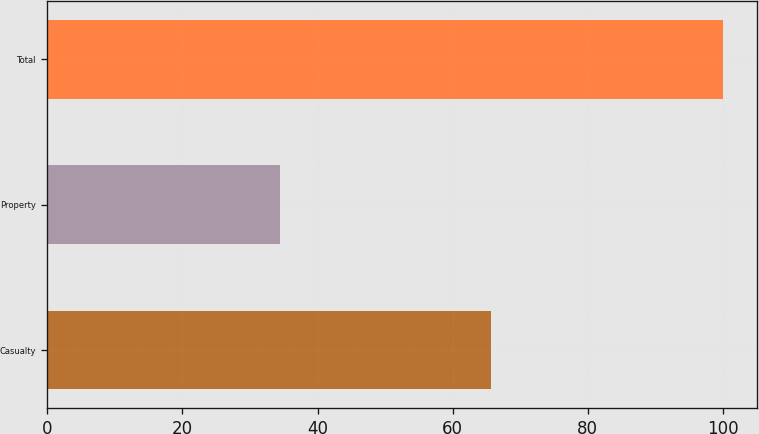Convert chart to OTSL. <chart><loc_0><loc_0><loc_500><loc_500><bar_chart><fcel>Casualty<fcel>Property<fcel>Total<nl><fcel>65.6<fcel>34.4<fcel>100<nl></chart> 